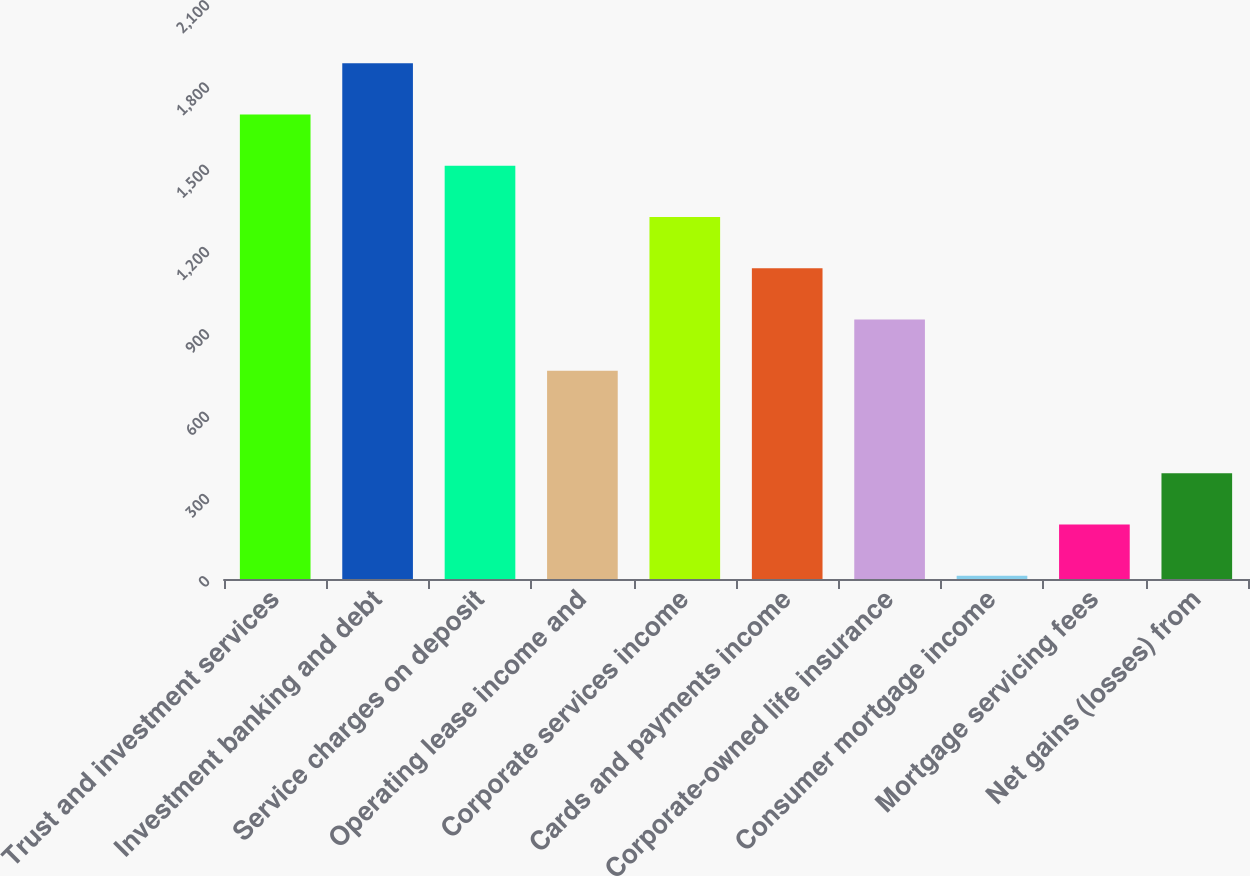Convert chart to OTSL. <chart><loc_0><loc_0><loc_500><loc_500><bar_chart><fcel>Trust and investment services<fcel>Investment banking and debt<fcel>Service charges on deposit<fcel>Operating lease income and<fcel>Corporate services income<fcel>Cards and payments income<fcel>Corporate-owned life insurance<fcel>Consumer mortgage income<fcel>Mortgage servicing fees<fcel>Net gains (losses) from<nl><fcel>1693.2<fcel>1880<fcel>1506.4<fcel>759.2<fcel>1319.6<fcel>1132.8<fcel>946<fcel>12<fcel>198.8<fcel>385.6<nl></chart> 